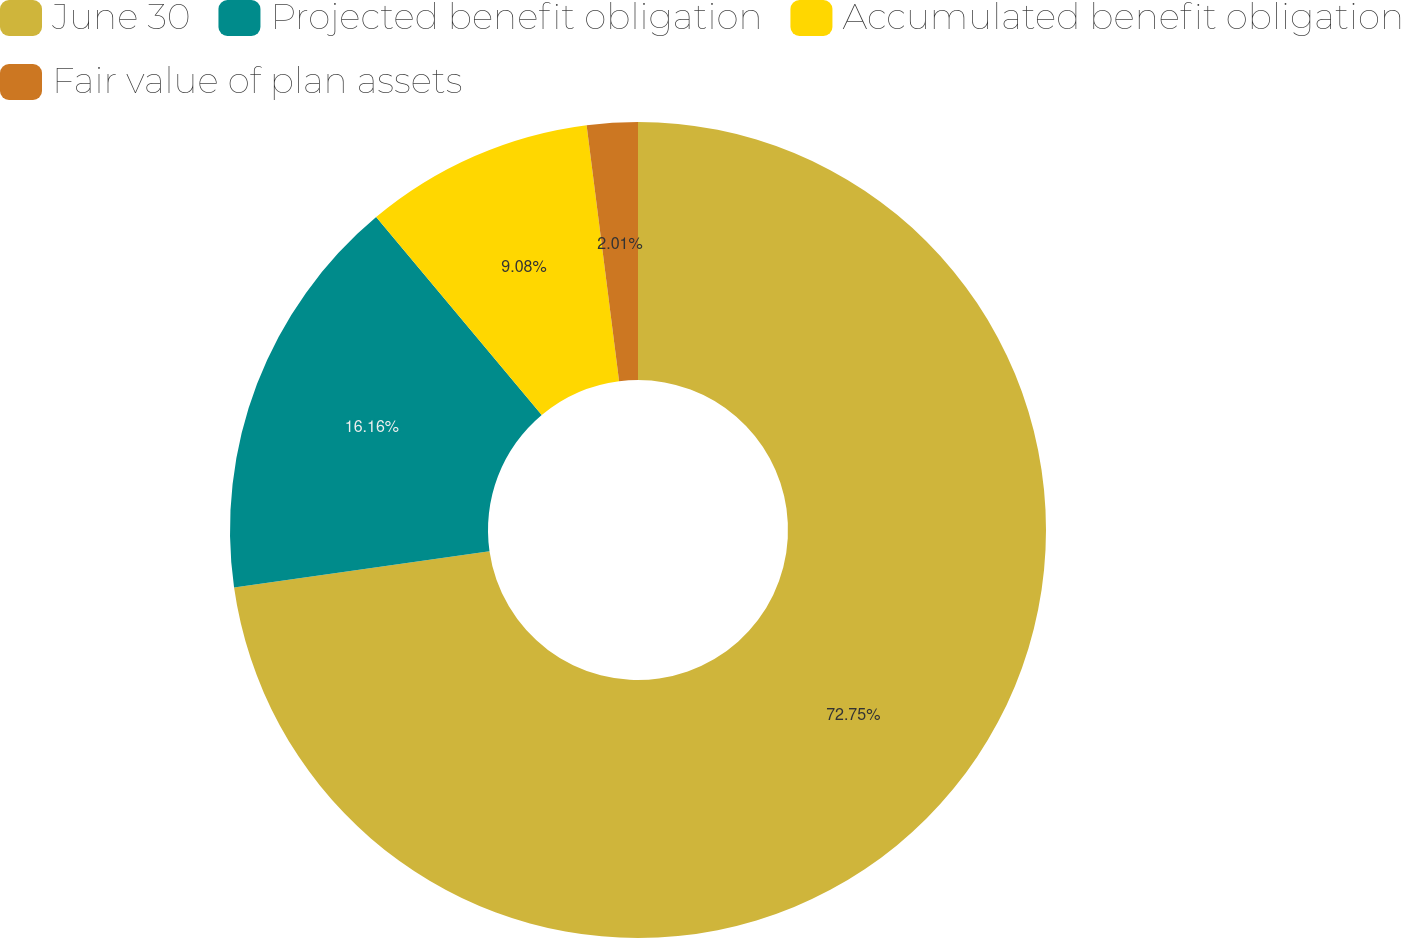Convert chart to OTSL. <chart><loc_0><loc_0><loc_500><loc_500><pie_chart><fcel>June 30<fcel>Projected benefit obligation<fcel>Accumulated benefit obligation<fcel>Fair value of plan assets<nl><fcel>72.75%<fcel>16.16%<fcel>9.08%<fcel>2.01%<nl></chart> 